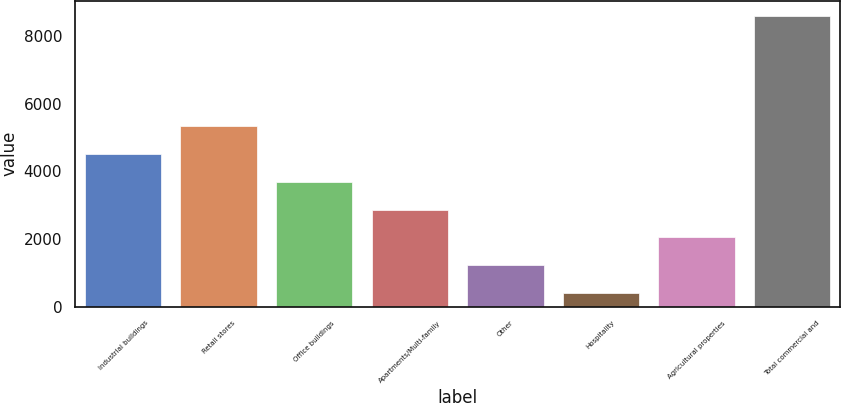Convert chart to OTSL. <chart><loc_0><loc_0><loc_500><loc_500><bar_chart><fcel>Industrial buildings<fcel>Retail stores<fcel>Office buildings<fcel>Apartments/Multi-family<fcel>Other<fcel>Hospitality<fcel>Agricultural properties<fcel>Total commercial and<nl><fcel>4507.5<fcel>5327.6<fcel>3687.4<fcel>2867.3<fcel>1227.1<fcel>407<fcel>2047.2<fcel>8608<nl></chart> 